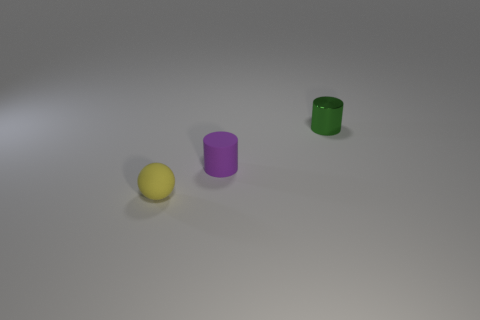What number of other objects are the same color as the tiny rubber sphere? 0 